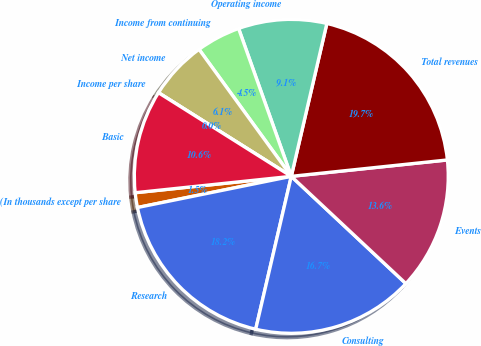<chart> <loc_0><loc_0><loc_500><loc_500><pie_chart><fcel>(In thousands except per share<fcel>Research<fcel>Consulting<fcel>Events<fcel>Total revenues<fcel>Operating income<fcel>Income from continuing<fcel>Net income<fcel>Income per share<fcel>Basic<nl><fcel>1.52%<fcel>18.18%<fcel>16.67%<fcel>13.64%<fcel>19.7%<fcel>9.09%<fcel>4.55%<fcel>6.06%<fcel>0.0%<fcel>10.61%<nl></chart> 